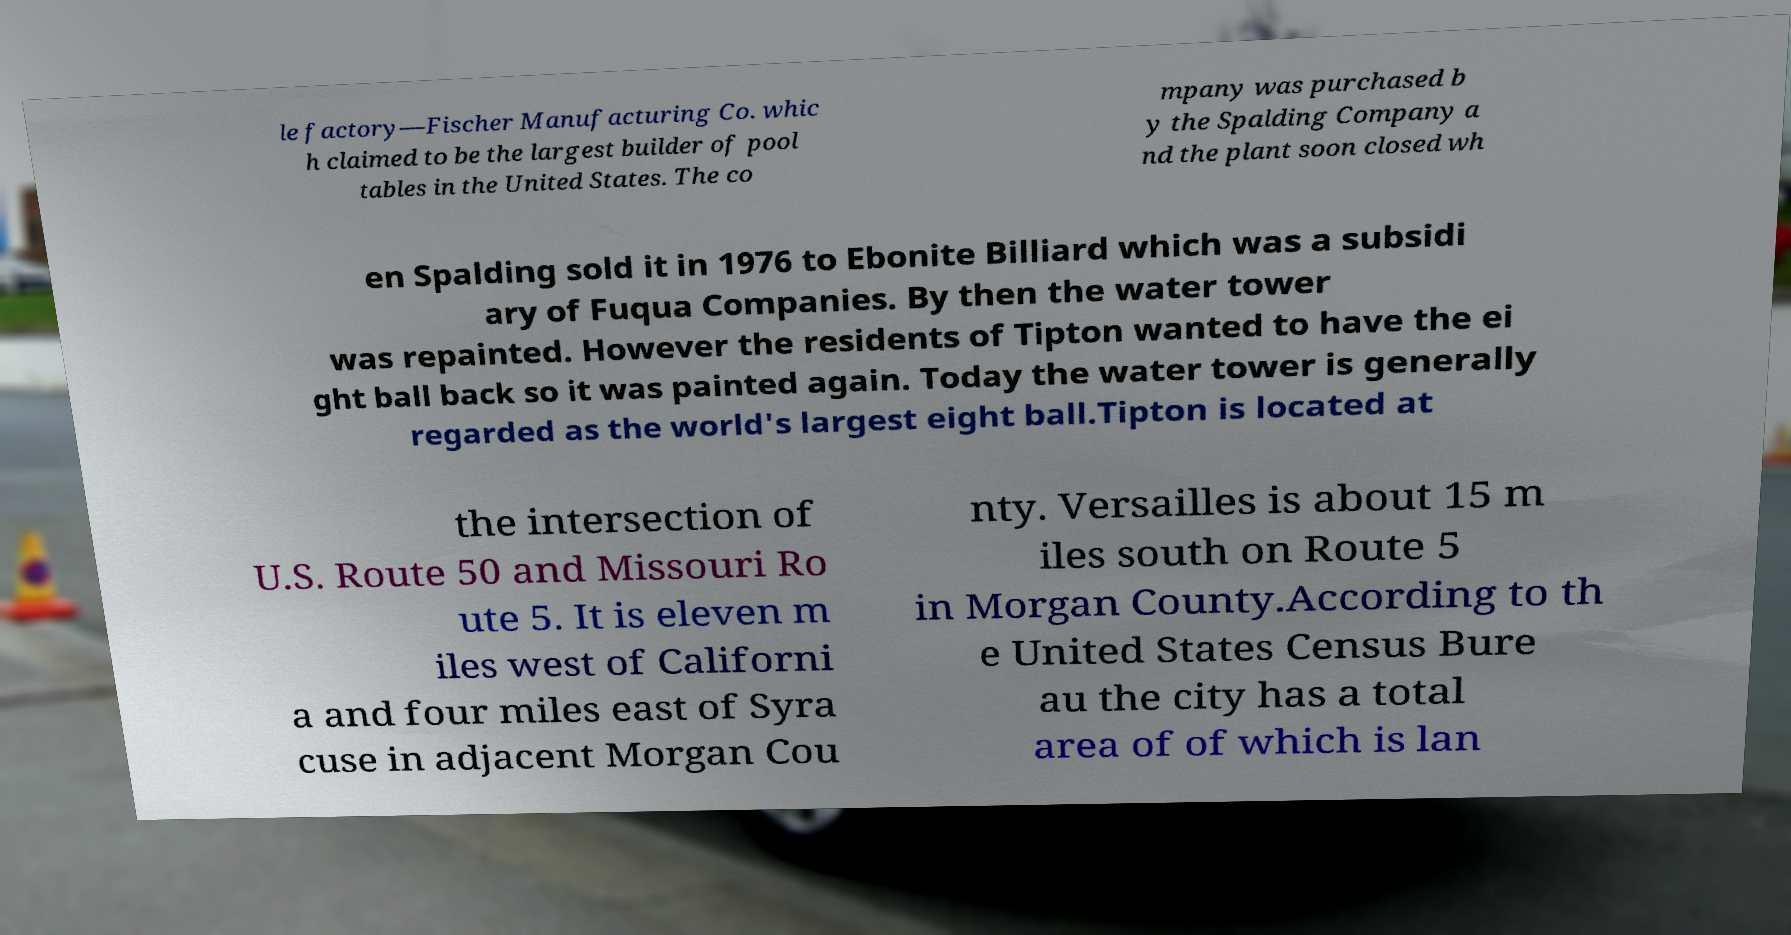Could you assist in decoding the text presented in this image and type it out clearly? le factory—Fischer Manufacturing Co. whic h claimed to be the largest builder of pool tables in the United States. The co mpany was purchased b y the Spalding Company a nd the plant soon closed wh en Spalding sold it in 1976 to Ebonite Billiard which was a subsidi ary of Fuqua Companies. By then the water tower was repainted. However the residents of Tipton wanted to have the ei ght ball back so it was painted again. Today the water tower is generally regarded as the world's largest eight ball.Tipton is located at the intersection of U.S. Route 50 and Missouri Ro ute 5. It is eleven m iles west of Californi a and four miles east of Syra cuse in adjacent Morgan Cou nty. Versailles is about 15 m iles south on Route 5 in Morgan County.According to th e United States Census Bure au the city has a total area of of which is lan 